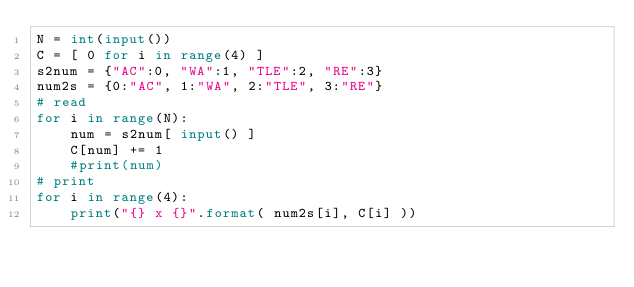Convert code to text. <code><loc_0><loc_0><loc_500><loc_500><_Python_>N = int(input())
C = [ 0 for i in range(4) ]
s2num = {"AC":0, "WA":1, "TLE":2, "RE":3}
num2s = {0:"AC", 1:"WA", 2:"TLE", 3:"RE"}
# read
for i in range(N):
    num = s2num[ input() ]
    C[num] += 1
    #print(num)
# print
for i in range(4):
    print("{} x {}".format( num2s[i], C[i] ))


</code> 